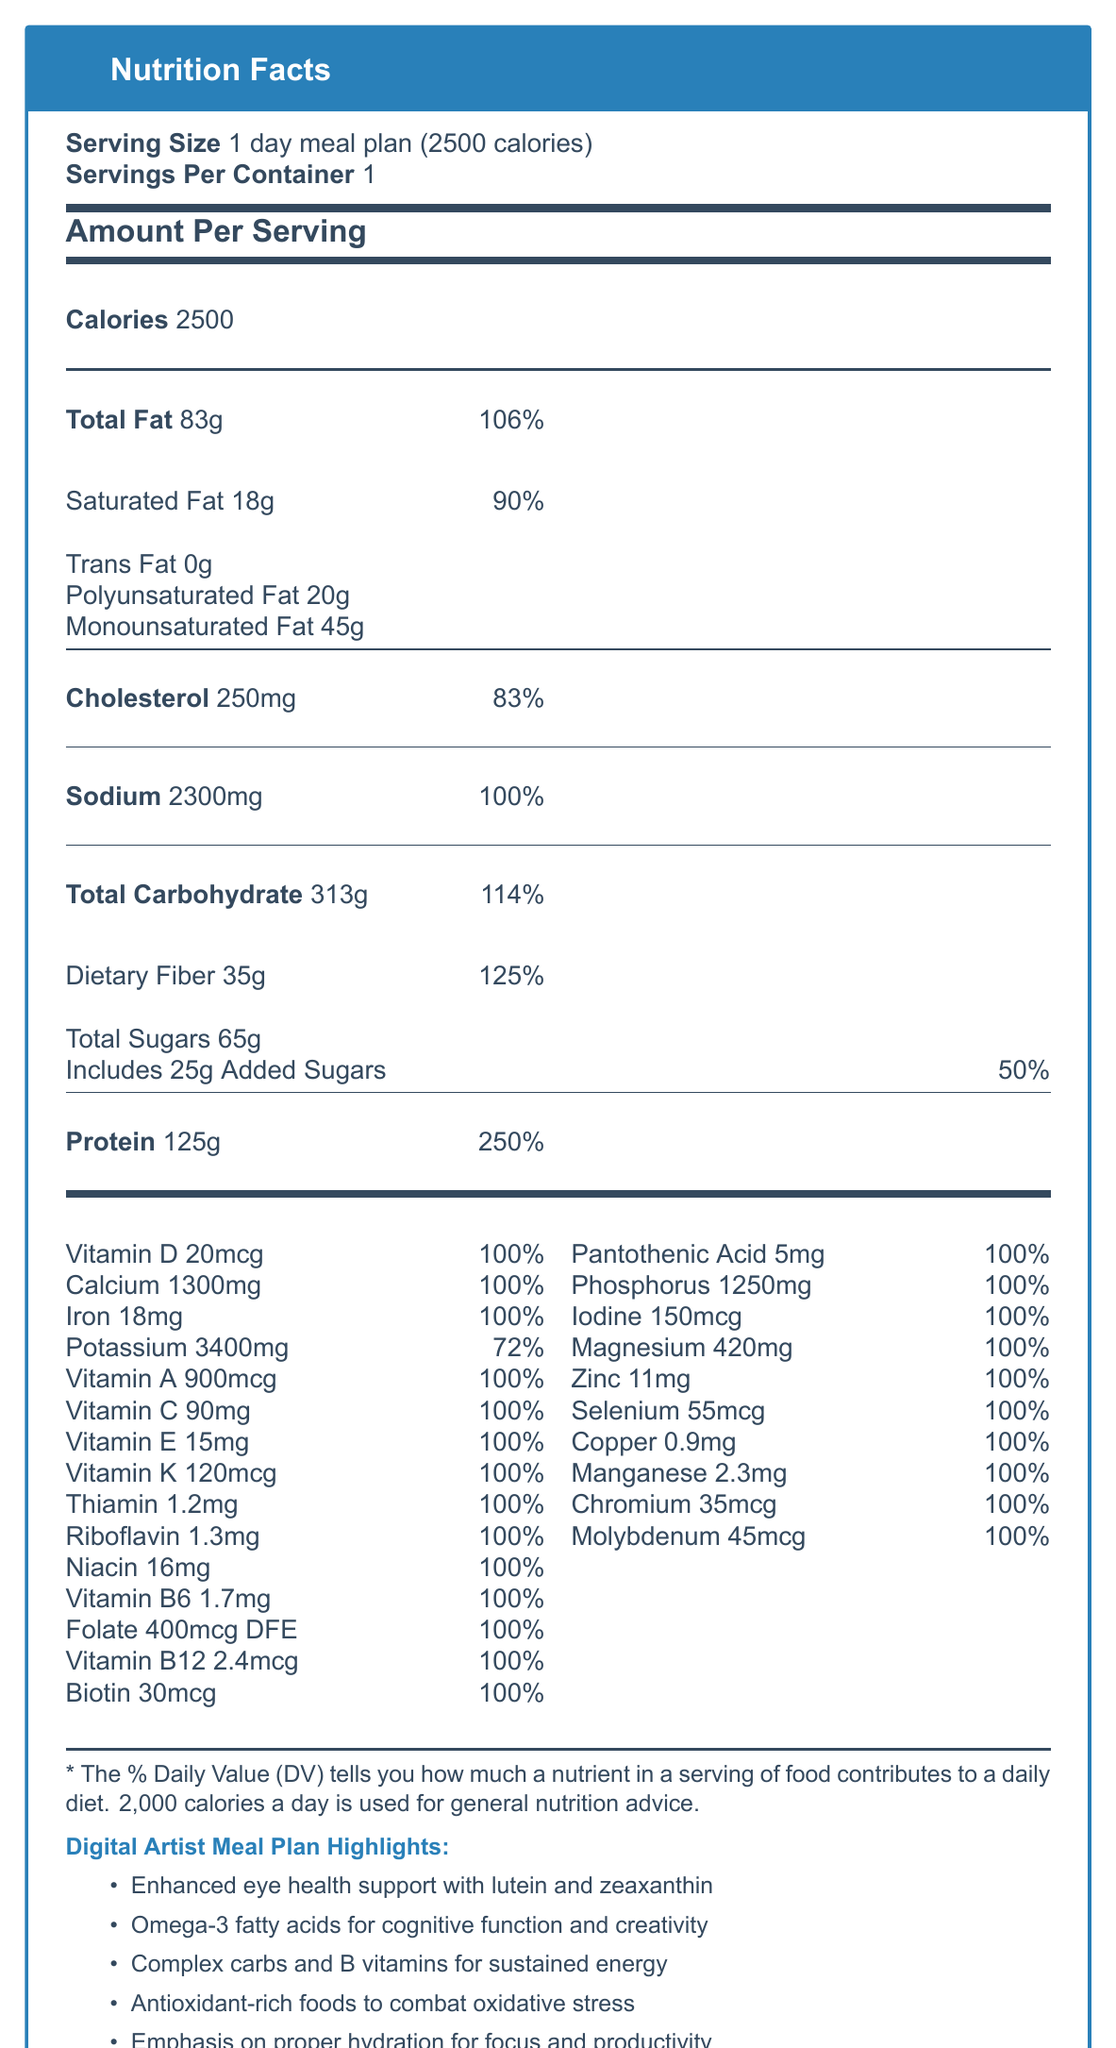what is the serving size for this meal plan? The serving size is specified at the beginning of the document as "1 day meal plan (2500 calories)".
Answer: 1 day meal plan (2500 calories) how much total fat is in the meal plan? Total fat amount is listed under the macronutrients section as "Total Fat 83g".
Answer: 83g what percentage of the daily value does the dietary fiber in the plan represent? The dietary fiber amount under the total carbohydrate indicates 35g which also represents 125% of the daily value.
Answer: 125% how much sodium is included in the meal plan? Sodium content is marked as "2300mg" and is also 100% of the daily value.
Answer: 2300mg how much protein is in the meal plan? Protein amount is specified in the document as "125g" which is 250% of the daily value.
Answer: 125g what items are included in the breakfast section? A. Poached eggs, Greek yogurt, Green tea B. Whole grain avocado toast with poached eggs, Greek yogurt with mixed berries and chia seeds, Green tea C. Whole grain bread with eggs, Greek yogurt, Orange juice Breakfast section lists "Whole grain avocado toast with poached eggs, Greek yogurt with mixed berries and chia seeds, Green tea".
Answer: B how much vitamin D is in the meal plan? A. 30mcg B. 20mcg C. 15mcg D. 10mcg Vitamin D amount is given as "20mcg" in the document.
Answer: B does the meal plan support brain function with Omega-3 fatty acids? The digital artist-specific notes explicitly mention Omega-3 fatty acids from salmon and chia seeds to enhance cognitive function and creativity.
Answer: Yes what are the main benefits summarized for digital artists? The document highlights specific nutritional benefits like eye health, cognitive function, sustained energy, antioxidants, and hydration for digital artists.
Answer: Enhanced eye health, cognitive function, sustained energy, antioxidants to combat oxidative stress, proper hydration what is the percentage daily value of potassium provided by the meal plan? Potassium daily value is listed as 3400mg which accounts for 72% of the daily value.
Answer: 72% what is the key point of this document? The document contains a detailed breakdown of the nutrition facts for a meal plan aimed at supporting digital artists, including specific macro and micronutrients and their corresponding daily values, insightful notes on how they benefit digital artists, and a summary of meal components.
Answer: The key point is to provide a detailed nutrition facts label for a daily meal plan (2500 calories) designed specifically to meet the nutritional needs of digital artists. It includes both macro and micronutrient information along with specific notes on supporting creative work and health. can you determine whether the plan accommodates vegan preferences? The document does not provide enough specific information to ascertain whether the meal plan is suitable for vegan preferences.
Answer: Cannot be determined how much added sugar is in the meal plan? The breakdown of total sugars under carbohydrates indicates that the meal plan includes 25g of added sugars representing 50% of the daily value.
Answer: 25g is the copper content in the meal plan sufficient to meet the daily required intake? The copper amount is listed as 0.9mg and is 100% of the daily value.
Answer: Yes 